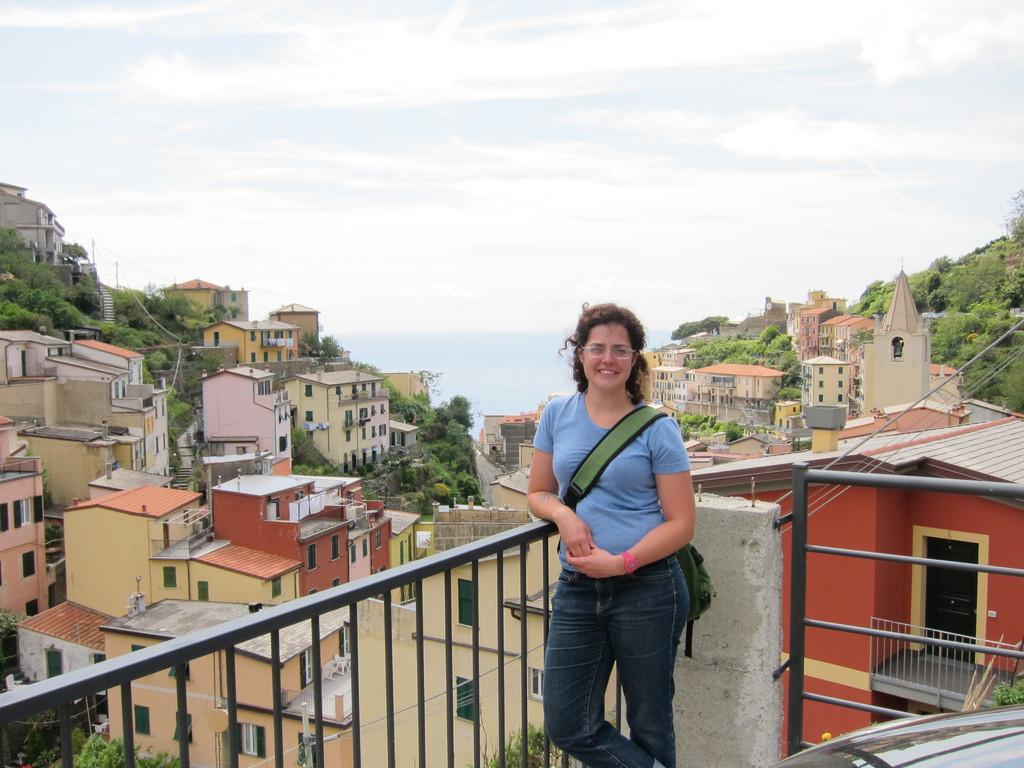What is the main subject of the image? The main subject of the image is a girl standing in the middle. What is the girl wearing in the image? The girl is wearing a blue t-shirt and jeans trousers. What can be seen in the background of the image? There are buildings, trees, and the sky visible in the image. What type of authority does the girl have in the image? There is no indication of authority in the image; it simply shows a girl standing in the middle. Can you see a whip in the girl's hand in the image? No, there is no whip present in the image. 